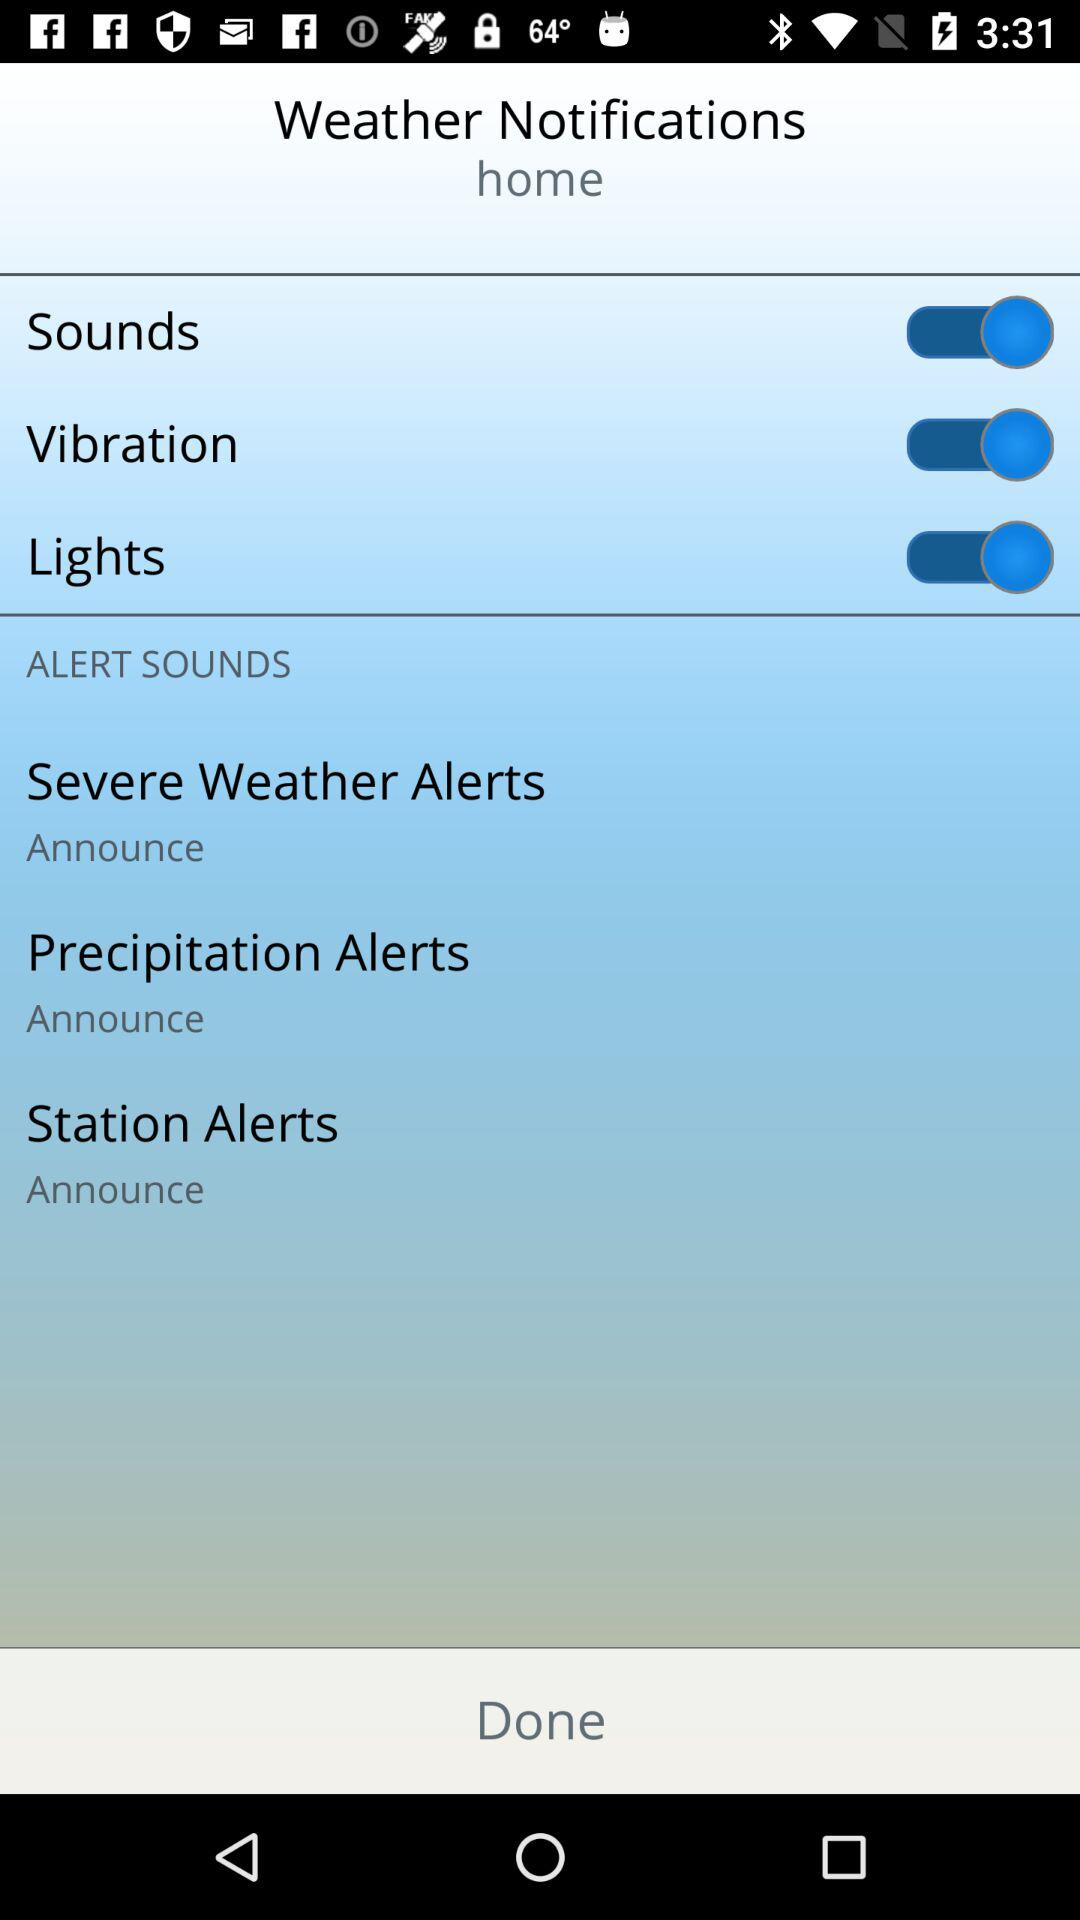How many alert types are available?
Answer the question using a single word or phrase. 3 